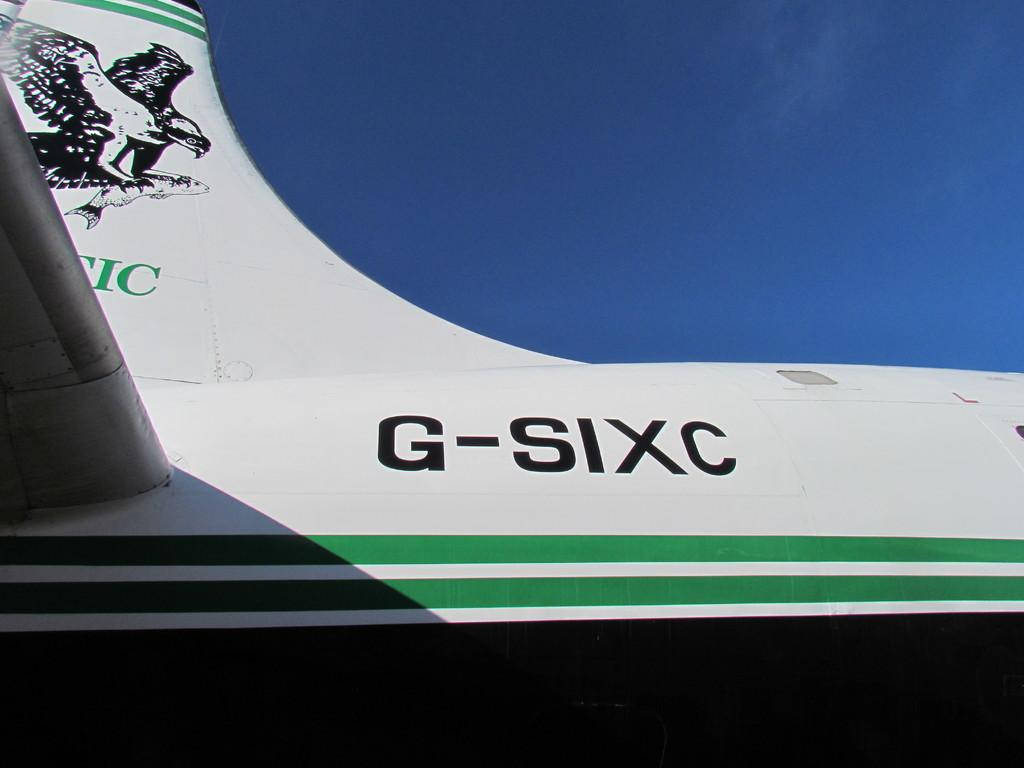<image>
Create a compact narrative representing the image presented. A green and white plane with the letters G-SIXC printed on the side. 